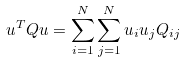Convert formula to latex. <formula><loc_0><loc_0><loc_500><loc_500>u ^ { T } Q u = \sum _ { i = 1 } ^ { N } \sum _ { j = 1 } ^ { N } u _ { i } u _ { j } Q _ { i j }</formula> 